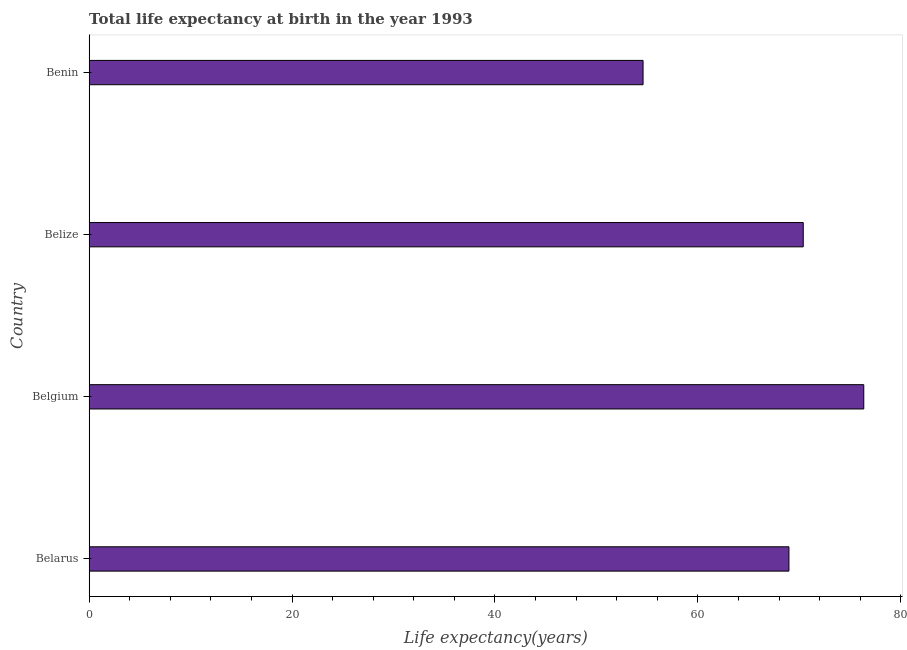Does the graph contain any zero values?
Your answer should be compact. No. Does the graph contain grids?
Keep it short and to the point. No. What is the title of the graph?
Give a very brief answer. Total life expectancy at birth in the year 1993. What is the label or title of the X-axis?
Offer a very short reply. Life expectancy(years). What is the life expectancy at birth in Belize?
Your response must be concise. 70.38. Across all countries, what is the maximum life expectancy at birth?
Your answer should be very brief. 76.35. Across all countries, what is the minimum life expectancy at birth?
Offer a terse response. 54.59. In which country was the life expectancy at birth maximum?
Keep it short and to the point. Belgium. In which country was the life expectancy at birth minimum?
Give a very brief answer. Benin. What is the sum of the life expectancy at birth?
Offer a terse response. 270.29. What is the difference between the life expectancy at birth in Belarus and Belgium?
Make the answer very short. -7.38. What is the average life expectancy at birth per country?
Offer a terse response. 67.57. What is the median life expectancy at birth?
Your answer should be compact. 69.68. In how many countries, is the life expectancy at birth greater than 72 years?
Offer a terse response. 1. What is the ratio of the life expectancy at birth in Belarus to that in Belgium?
Your response must be concise. 0.9. Is the difference between the life expectancy at birth in Belgium and Benin greater than the difference between any two countries?
Your answer should be compact. Yes. What is the difference between the highest and the second highest life expectancy at birth?
Provide a succinct answer. 5.96. What is the difference between the highest and the lowest life expectancy at birth?
Your answer should be compact. 21.75. In how many countries, is the life expectancy at birth greater than the average life expectancy at birth taken over all countries?
Make the answer very short. 3. Are all the bars in the graph horizontal?
Provide a succinct answer. Yes. What is the Life expectancy(years) in Belarus?
Offer a terse response. 68.97. What is the Life expectancy(years) in Belgium?
Your answer should be very brief. 76.35. What is the Life expectancy(years) in Belize?
Offer a terse response. 70.38. What is the Life expectancy(years) of Benin?
Provide a succinct answer. 54.59. What is the difference between the Life expectancy(years) in Belarus and Belgium?
Offer a very short reply. -7.37. What is the difference between the Life expectancy(years) in Belarus and Belize?
Give a very brief answer. -1.41. What is the difference between the Life expectancy(years) in Belarus and Benin?
Provide a succinct answer. 14.38. What is the difference between the Life expectancy(years) in Belgium and Belize?
Make the answer very short. 5.96. What is the difference between the Life expectancy(years) in Belgium and Benin?
Offer a terse response. 21.75. What is the difference between the Life expectancy(years) in Belize and Benin?
Your answer should be compact. 15.79. What is the ratio of the Life expectancy(years) in Belarus to that in Belgium?
Ensure brevity in your answer.  0.9. What is the ratio of the Life expectancy(years) in Belarus to that in Belize?
Provide a succinct answer. 0.98. What is the ratio of the Life expectancy(years) in Belarus to that in Benin?
Ensure brevity in your answer.  1.26. What is the ratio of the Life expectancy(years) in Belgium to that in Belize?
Give a very brief answer. 1.08. What is the ratio of the Life expectancy(years) in Belgium to that in Benin?
Your response must be concise. 1.4. What is the ratio of the Life expectancy(years) in Belize to that in Benin?
Provide a succinct answer. 1.29. 